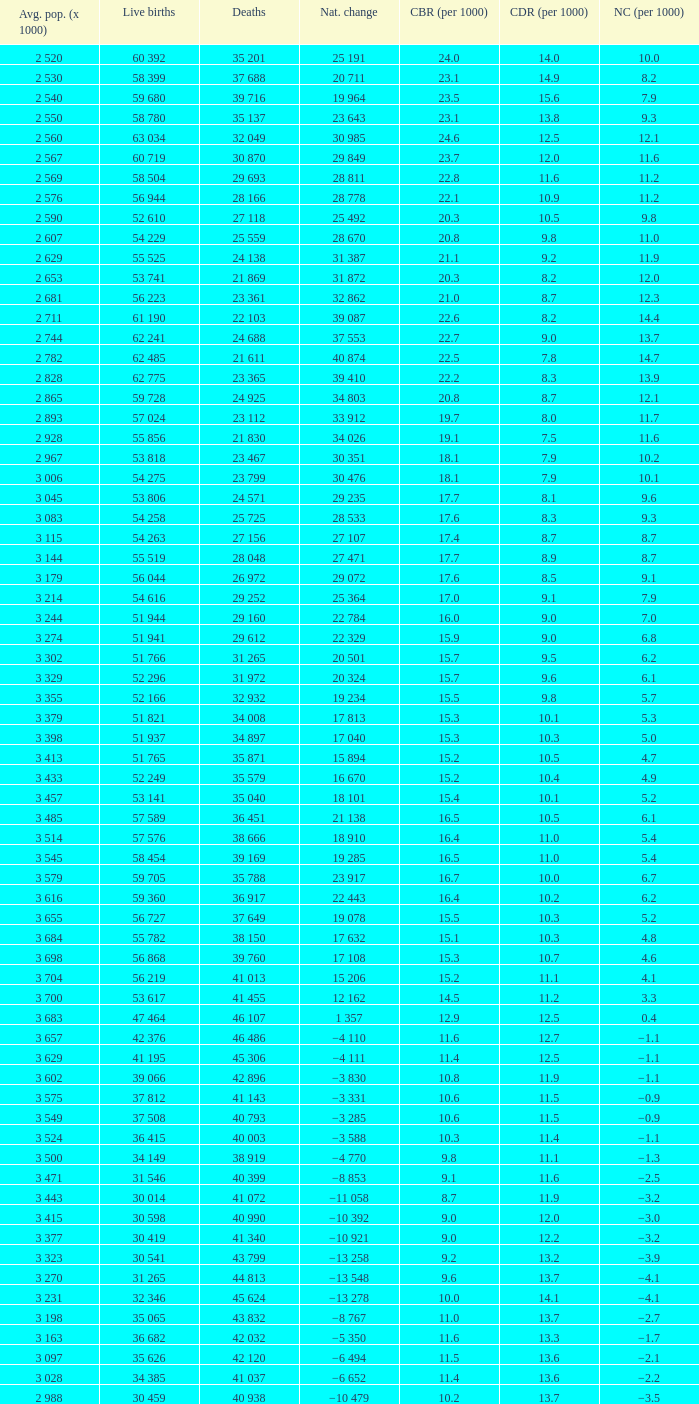Could you parse the entire table as a dict? {'header': ['Avg. pop. (x 1000)', 'Live births', 'Deaths', 'Nat. change', 'CBR (per 1000)', 'CDR (per 1000)', 'NC (per 1000)'], 'rows': [['2 520', '60 392', '35 201', '25 191', '24.0', '14.0', '10.0'], ['2 530', '58 399', '37 688', '20 711', '23.1', '14.9', '8.2'], ['2 540', '59 680', '39 716', '19 964', '23.5', '15.6', '7.9'], ['2 550', '58 780', '35 137', '23 643', '23.1', '13.8', '9.3'], ['2 560', '63 034', '32 049', '30 985', '24.6', '12.5', '12.1'], ['2 567', '60 719', '30 870', '29 849', '23.7', '12.0', '11.6'], ['2 569', '58 504', '29 693', '28 811', '22.8', '11.6', '11.2'], ['2 576', '56 944', '28 166', '28 778', '22.1', '10.9', '11.2'], ['2 590', '52 610', '27 118', '25 492', '20.3', '10.5', '9.8'], ['2 607', '54 229', '25 559', '28 670', '20.8', '9.8', '11.0'], ['2 629', '55 525', '24 138', '31 387', '21.1', '9.2', '11.9'], ['2 653', '53 741', '21 869', '31 872', '20.3', '8.2', '12.0'], ['2 681', '56 223', '23 361', '32 862', '21.0', '8.7', '12.3'], ['2 711', '61 190', '22 103', '39 087', '22.6', '8.2', '14.4'], ['2 744', '62 241', '24 688', '37 553', '22.7', '9.0', '13.7'], ['2 782', '62 485', '21 611', '40 874', '22.5', '7.8', '14.7'], ['2 828', '62 775', '23 365', '39 410', '22.2', '8.3', '13.9'], ['2 865', '59 728', '24 925', '34 803', '20.8', '8.7', '12.1'], ['2 893', '57 024', '23 112', '33 912', '19.7', '8.0', '11.7'], ['2 928', '55 856', '21 830', '34 026', '19.1', '7.5', '11.6'], ['2 967', '53 818', '23 467', '30 351', '18.1', '7.9', '10.2'], ['3 006', '54 275', '23 799', '30 476', '18.1', '7.9', '10.1'], ['3 045', '53 806', '24 571', '29 235', '17.7', '8.1', '9.6'], ['3 083', '54 258', '25 725', '28 533', '17.6', '8.3', '9.3'], ['3 115', '54 263', '27 156', '27 107', '17.4', '8.7', '8.7'], ['3 144', '55 519', '28 048', '27 471', '17.7', '8.9', '8.7'], ['3 179', '56 044', '26 972', '29 072', '17.6', '8.5', '9.1'], ['3 214', '54 616', '29 252', '25 364', '17.0', '9.1', '7.9'], ['3 244', '51 944', '29 160', '22 784', '16.0', '9.0', '7.0'], ['3 274', '51 941', '29 612', '22 329', '15.9', '9.0', '6.8'], ['3 302', '51 766', '31 265', '20 501', '15.7', '9.5', '6.2'], ['3 329', '52 296', '31 972', '20 324', '15.7', '9.6', '6.1'], ['3 355', '52 166', '32 932', '19 234', '15.5', '9.8', '5.7'], ['3 379', '51 821', '34 008', '17 813', '15.3', '10.1', '5.3'], ['3 398', '51 937', '34 897', '17 040', '15.3', '10.3', '5.0'], ['3 413', '51 765', '35 871', '15 894', '15.2', '10.5', '4.7'], ['3 433', '52 249', '35 579', '16 670', '15.2', '10.4', '4.9'], ['3 457', '53 141', '35 040', '18 101', '15.4', '10.1', '5.2'], ['3 485', '57 589', '36 451', '21 138', '16.5', '10.5', '6.1'], ['3 514', '57 576', '38 666', '18 910', '16.4', '11.0', '5.4'], ['3 545', '58 454', '39 169', '19 285', '16.5', '11.0', '5.4'], ['3 579', '59 705', '35 788', '23 917', '16.7', '10.0', '6.7'], ['3 616', '59 360', '36 917', '22 443', '16.4', '10.2', '6.2'], ['3 655', '56 727', '37 649', '19 078', '15.5', '10.3', '5.2'], ['3 684', '55 782', '38 150', '17 632', '15.1', '10.3', '4.8'], ['3 698', '56 868', '39 760', '17 108', '15.3', '10.7', '4.6'], ['3 704', '56 219', '41 013', '15 206', '15.2', '11.1', '4.1'], ['3 700', '53 617', '41 455', '12 162', '14.5', '11.2', '3.3'], ['3 683', '47 464', '46 107', '1 357', '12.9', '12.5', '0.4'], ['3 657', '42 376', '46 486', '−4 110', '11.6', '12.7', '−1.1'], ['3 629', '41 195', '45 306', '−4 111', '11.4', '12.5', '−1.1'], ['3 602', '39 066', '42 896', '−3 830', '10.8', '11.9', '−1.1'], ['3 575', '37 812', '41 143', '−3 331', '10.6', '11.5', '−0.9'], ['3 549', '37 508', '40 793', '−3 285', '10.6', '11.5', '−0.9'], ['3 524', '36 415', '40 003', '−3 588', '10.3', '11.4', '−1.1'], ['3 500', '34 149', '38 919', '−4 770', '9.8', '11.1', '−1.3'], ['3 471', '31 546', '40 399', '−8 853', '9.1', '11.6', '−2.5'], ['3 443', '30 014', '41 072', '−11 058', '8.7', '11.9', '−3.2'], ['3 415', '30 598', '40 990', '−10 392', '9.0', '12.0', '−3.0'], ['3 377', '30 419', '41 340', '−10 921', '9.0', '12.2', '−3.2'], ['3 323', '30 541', '43 799', '−13 258', '9.2', '13.2', '−3.9'], ['3 270', '31 265', '44 813', '−13 548', '9.6', '13.7', '−4.1'], ['3 231', '32 346', '45 624', '−13 278', '10.0', '14.1', '−4.1'], ['3 198', '35 065', '43 832', '−8 767', '11.0', '13.7', '−2.7'], ['3 163', '36 682', '42 032', '−5 350', '11.6', '13.3', '−1.7'], ['3 097', '35 626', '42 120', '−6 494', '11.5', '13.6', '−2.1'], ['3 028', '34 385', '41 037', '−6 652', '11.4', '13.6', '−2.2'], ['2 988', '30 459', '40 938', '−10 479', '10.2', '13.7', '−3.5']]} Which Live births have a Natural change (per 1000) of 12.0? 53 741. 